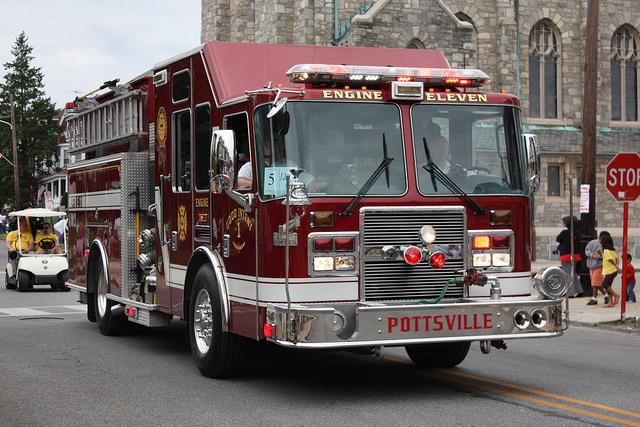Which side of the road is the fire truck driving on? Please explain your reasoning. middle. The truck is driving directly over the yellow line which is always in the middle of the road. 